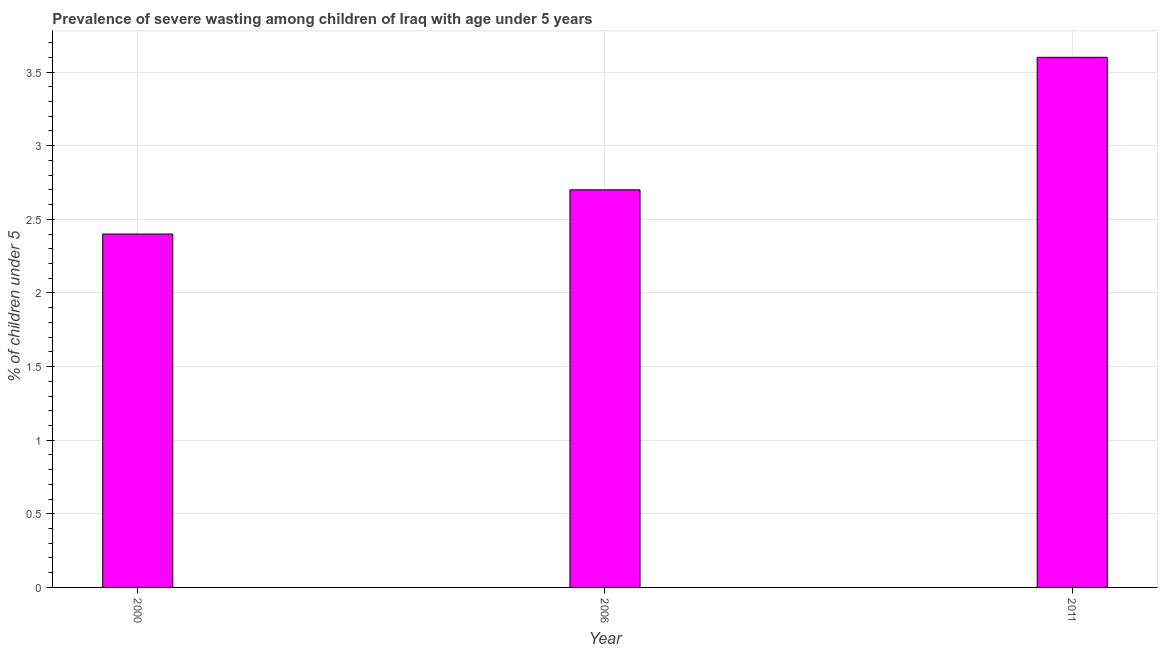Does the graph contain any zero values?
Your answer should be compact. No. What is the title of the graph?
Ensure brevity in your answer.  Prevalence of severe wasting among children of Iraq with age under 5 years. What is the label or title of the X-axis?
Offer a terse response. Year. What is the label or title of the Y-axis?
Provide a succinct answer.  % of children under 5. What is the prevalence of severe wasting in 2006?
Ensure brevity in your answer.  2.7. Across all years, what is the maximum prevalence of severe wasting?
Ensure brevity in your answer.  3.6. Across all years, what is the minimum prevalence of severe wasting?
Your answer should be very brief. 2.4. In which year was the prevalence of severe wasting maximum?
Make the answer very short. 2011. What is the sum of the prevalence of severe wasting?
Keep it short and to the point. 8.7. What is the difference between the prevalence of severe wasting in 2000 and 2006?
Your answer should be compact. -0.3. What is the average prevalence of severe wasting per year?
Your answer should be very brief. 2.9. What is the median prevalence of severe wasting?
Give a very brief answer. 2.7. In how many years, is the prevalence of severe wasting greater than 2.8 %?
Give a very brief answer. 1. Do a majority of the years between 2011 and 2006 (inclusive) have prevalence of severe wasting greater than 1.8 %?
Offer a terse response. No. What is the ratio of the prevalence of severe wasting in 2000 to that in 2006?
Ensure brevity in your answer.  0.89. What is the difference between the highest and the second highest prevalence of severe wasting?
Your response must be concise. 0.9. In how many years, is the prevalence of severe wasting greater than the average prevalence of severe wasting taken over all years?
Offer a terse response. 1. What is the difference between two consecutive major ticks on the Y-axis?
Offer a very short reply. 0.5. What is the  % of children under 5 in 2000?
Your answer should be very brief. 2.4. What is the  % of children under 5 in 2006?
Offer a terse response. 2.7. What is the  % of children under 5 of 2011?
Your answer should be compact. 3.6. What is the difference between the  % of children under 5 in 2000 and 2006?
Ensure brevity in your answer.  -0.3. What is the difference between the  % of children under 5 in 2006 and 2011?
Offer a very short reply. -0.9. What is the ratio of the  % of children under 5 in 2000 to that in 2006?
Give a very brief answer. 0.89. What is the ratio of the  % of children under 5 in 2000 to that in 2011?
Your answer should be compact. 0.67. 